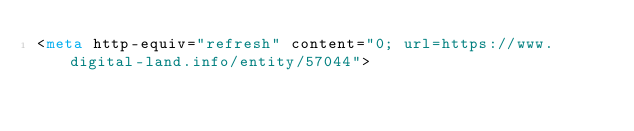<code> <loc_0><loc_0><loc_500><loc_500><_HTML_><meta http-equiv="refresh" content="0; url=https://www.digital-land.info/entity/57044"></code> 